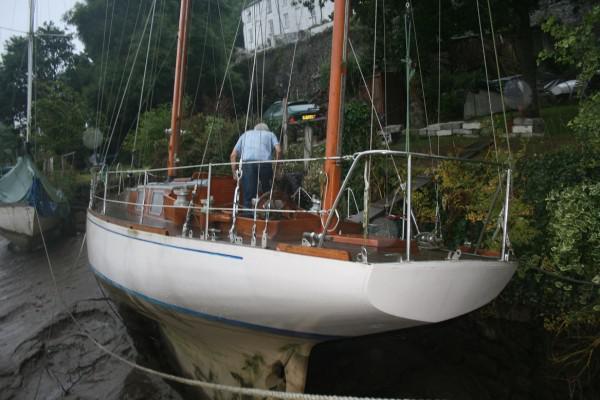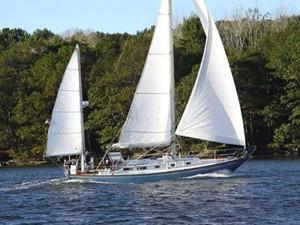The first image is the image on the left, the second image is the image on the right. Given the left and right images, does the statement "There is a single boat on the water with exactly 3 white sails open, that are being used to move the boat." hold true? Answer yes or no. Yes. The first image is the image on the left, the second image is the image on the right. Assess this claim about the two images: "in at least one image there is a single  boat with 3 sails". Correct or not? Answer yes or no. Yes. 